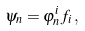<formula> <loc_0><loc_0><loc_500><loc_500>\psi _ { n } = \varphi _ { n } ^ { i } f _ { i } \, ,</formula> 